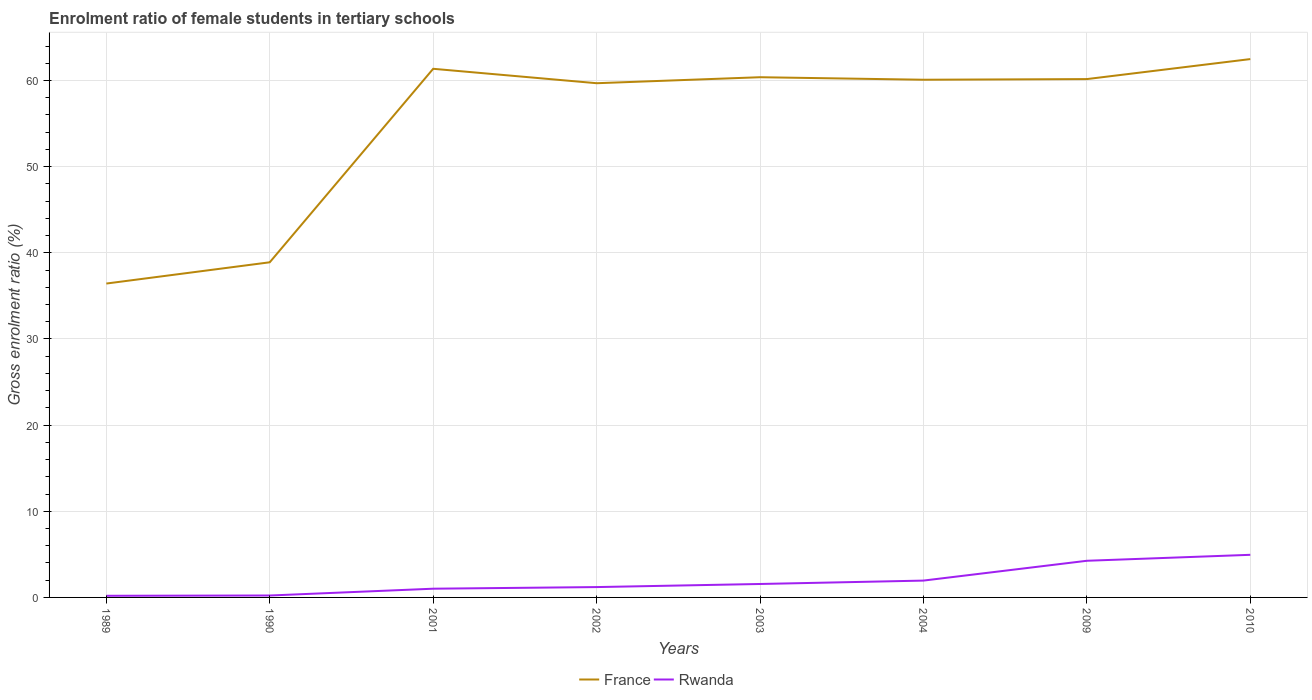How many different coloured lines are there?
Ensure brevity in your answer.  2. Across all years, what is the maximum enrolment ratio of female students in tertiary schools in Rwanda?
Your answer should be compact. 0.19. In which year was the enrolment ratio of female students in tertiary schools in France maximum?
Your answer should be compact. 1989. What is the total enrolment ratio of female students in tertiary schools in Rwanda in the graph?
Give a very brief answer. -2.69. What is the difference between the highest and the second highest enrolment ratio of female students in tertiary schools in France?
Offer a terse response. 26.05. What is the difference between the highest and the lowest enrolment ratio of female students in tertiary schools in Rwanda?
Provide a succinct answer. 3. How many lines are there?
Provide a succinct answer. 2. How many years are there in the graph?
Keep it short and to the point. 8. What is the title of the graph?
Your answer should be very brief. Enrolment ratio of female students in tertiary schools. Does "Ireland" appear as one of the legend labels in the graph?
Keep it short and to the point. No. What is the label or title of the Y-axis?
Offer a terse response. Gross enrolment ratio (%). What is the Gross enrolment ratio (%) of France in 1989?
Your answer should be compact. 36.43. What is the Gross enrolment ratio (%) of Rwanda in 1989?
Keep it short and to the point. 0.19. What is the Gross enrolment ratio (%) of France in 1990?
Provide a short and direct response. 38.9. What is the Gross enrolment ratio (%) in Rwanda in 1990?
Give a very brief answer. 0.22. What is the Gross enrolment ratio (%) of France in 2001?
Provide a succinct answer. 61.36. What is the Gross enrolment ratio (%) of Rwanda in 2001?
Provide a short and direct response. 1.01. What is the Gross enrolment ratio (%) in France in 2002?
Offer a very short reply. 59.68. What is the Gross enrolment ratio (%) of Rwanda in 2002?
Make the answer very short. 1.2. What is the Gross enrolment ratio (%) of France in 2003?
Offer a very short reply. 60.38. What is the Gross enrolment ratio (%) of Rwanda in 2003?
Provide a short and direct response. 1.56. What is the Gross enrolment ratio (%) in France in 2004?
Provide a short and direct response. 60.09. What is the Gross enrolment ratio (%) of Rwanda in 2004?
Your response must be concise. 1.95. What is the Gross enrolment ratio (%) of France in 2009?
Provide a short and direct response. 60.16. What is the Gross enrolment ratio (%) in Rwanda in 2009?
Provide a short and direct response. 4.25. What is the Gross enrolment ratio (%) in France in 2010?
Keep it short and to the point. 62.48. What is the Gross enrolment ratio (%) in Rwanda in 2010?
Ensure brevity in your answer.  4.95. Across all years, what is the maximum Gross enrolment ratio (%) in France?
Offer a terse response. 62.48. Across all years, what is the maximum Gross enrolment ratio (%) of Rwanda?
Offer a very short reply. 4.95. Across all years, what is the minimum Gross enrolment ratio (%) in France?
Offer a terse response. 36.43. Across all years, what is the minimum Gross enrolment ratio (%) of Rwanda?
Provide a short and direct response. 0.19. What is the total Gross enrolment ratio (%) in France in the graph?
Keep it short and to the point. 439.49. What is the total Gross enrolment ratio (%) in Rwanda in the graph?
Offer a terse response. 15.35. What is the difference between the Gross enrolment ratio (%) in France in 1989 and that in 1990?
Keep it short and to the point. -2.47. What is the difference between the Gross enrolment ratio (%) of Rwanda in 1989 and that in 1990?
Provide a short and direct response. -0.03. What is the difference between the Gross enrolment ratio (%) of France in 1989 and that in 2001?
Your answer should be compact. -24.93. What is the difference between the Gross enrolment ratio (%) in Rwanda in 1989 and that in 2001?
Your answer should be very brief. -0.82. What is the difference between the Gross enrolment ratio (%) of France in 1989 and that in 2002?
Ensure brevity in your answer.  -23.25. What is the difference between the Gross enrolment ratio (%) in Rwanda in 1989 and that in 2002?
Ensure brevity in your answer.  -1.01. What is the difference between the Gross enrolment ratio (%) in France in 1989 and that in 2003?
Provide a short and direct response. -23.95. What is the difference between the Gross enrolment ratio (%) in Rwanda in 1989 and that in 2003?
Provide a succinct answer. -1.37. What is the difference between the Gross enrolment ratio (%) in France in 1989 and that in 2004?
Give a very brief answer. -23.66. What is the difference between the Gross enrolment ratio (%) of Rwanda in 1989 and that in 2004?
Your response must be concise. -1.76. What is the difference between the Gross enrolment ratio (%) of France in 1989 and that in 2009?
Your response must be concise. -23.73. What is the difference between the Gross enrolment ratio (%) in Rwanda in 1989 and that in 2009?
Offer a very short reply. -4.06. What is the difference between the Gross enrolment ratio (%) of France in 1989 and that in 2010?
Make the answer very short. -26.05. What is the difference between the Gross enrolment ratio (%) in Rwanda in 1989 and that in 2010?
Give a very brief answer. -4.75. What is the difference between the Gross enrolment ratio (%) of France in 1990 and that in 2001?
Make the answer very short. -22.46. What is the difference between the Gross enrolment ratio (%) of Rwanda in 1990 and that in 2001?
Your response must be concise. -0.79. What is the difference between the Gross enrolment ratio (%) in France in 1990 and that in 2002?
Make the answer very short. -20.78. What is the difference between the Gross enrolment ratio (%) of Rwanda in 1990 and that in 2002?
Make the answer very short. -0.98. What is the difference between the Gross enrolment ratio (%) of France in 1990 and that in 2003?
Give a very brief answer. -21.48. What is the difference between the Gross enrolment ratio (%) of Rwanda in 1990 and that in 2003?
Keep it short and to the point. -1.34. What is the difference between the Gross enrolment ratio (%) of France in 1990 and that in 2004?
Give a very brief answer. -21.19. What is the difference between the Gross enrolment ratio (%) in Rwanda in 1990 and that in 2004?
Offer a terse response. -1.73. What is the difference between the Gross enrolment ratio (%) in France in 1990 and that in 2009?
Your answer should be very brief. -21.26. What is the difference between the Gross enrolment ratio (%) of Rwanda in 1990 and that in 2009?
Your answer should be compact. -4.03. What is the difference between the Gross enrolment ratio (%) of France in 1990 and that in 2010?
Your answer should be compact. -23.59. What is the difference between the Gross enrolment ratio (%) in Rwanda in 1990 and that in 2010?
Your answer should be compact. -4.72. What is the difference between the Gross enrolment ratio (%) in France in 2001 and that in 2002?
Your answer should be compact. 1.67. What is the difference between the Gross enrolment ratio (%) in Rwanda in 2001 and that in 2002?
Offer a very short reply. -0.19. What is the difference between the Gross enrolment ratio (%) in France in 2001 and that in 2003?
Your answer should be compact. 0.98. What is the difference between the Gross enrolment ratio (%) in Rwanda in 2001 and that in 2003?
Offer a terse response. -0.55. What is the difference between the Gross enrolment ratio (%) in France in 2001 and that in 2004?
Make the answer very short. 1.27. What is the difference between the Gross enrolment ratio (%) in Rwanda in 2001 and that in 2004?
Make the answer very short. -0.94. What is the difference between the Gross enrolment ratio (%) in France in 2001 and that in 2009?
Keep it short and to the point. 1.2. What is the difference between the Gross enrolment ratio (%) in Rwanda in 2001 and that in 2009?
Your response must be concise. -3.24. What is the difference between the Gross enrolment ratio (%) in France in 2001 and that in 2010?
Provide a short and direct response. -1.13. What is the difference between the Gross enrolment ratio (%) in Rwanda in 2001 and that in 2010?
Provide a short and direct response. -3.93. What is the difference between the Gross enrolment ratio (%) of France in 2002 and that in 2003?
Your response must be concise. -0.7. What is the difference between the Gross enrolment ratio (%) in Rwanda in 2002 and that in 2003?
Your answer should be very brief. -0.36. What is the difference between the Gross enrolment ratio (%) in France in 2002 and that in 2004?
Your answer should be very brief. -0.4. What is the difference between the Gross enrolment ratio (%) in Rwanda in 2002 and that in 2004?
Give a very brief answer. -0.75. What is the difference between the Gross enrolment ratio (%) in France in 2002 and that in 2009?
Your response must be concise. -0.48. What is the difference between the Gross enrolment ratio (%) in Rwanda in 2002 and that in 2009?
Your answer should be very brief. -3.05. What is the difference between the Gross enrolment ratio (%) in France in 2002 and that in 2010?
Give a very brief answer. -2.8. What is the difference between the Gross enrolment ratio (%) in Rwanda in 2002 and that in 2010?
Provide a short and direct response. -3.75. What is the difference between the Gross enrolment ratio (%) of France in 2003 and that in 2004?
Ensure brevity in your answer.  0.29. What is the difference between the Gross enrolment ratio (%) in Rwanda in 2003 and that in 2004?
Keep it short and to the point. -0.39. What is the difference between the Gross enrolment ratio (%) in France in 2003 and that in 2009?
Provide a succinct answer. 0.22. What is the difference between the Gross enrolment ratio (%) of Rwanda in 2003 and that in 2009?
Provide a succinct answer. -2.69. What is the difference between the Gross enrolment ratio (%) of France in 2003 and that in 2010?
Your answer should be very brief. -2.1. What is the difference between the Gross enrolment ratio (%) of Rwanda in 2003 and that in 2010?
Provide a short and direct response. -3.39. What is the difference between the Gross enrolment ratio (%) in France in 2004 and that in 2009?
Offer a terse response. -0.07. What is the difference between the Gross enrolment ratio (%) of Rwanda in 2004 and that in 2009?
Provide a short and direct response. -2.3. What is the difference between the Gross enrolment ratio (%) in France in 2004 and that in 2010?
Make the answer very short. -2.4. What is the difference between the Gross enrolment ratio (%) of Rwanda in 2004 and that in 2010?
Ensure brevity in your answer.  -2.99. What is the difference between the Gross enrolment ratio (%) of France in 2009 and that in 2010?
Give a very brief answer. -2.32. What is the difference between the Gross enrolment ratio (%) in Rwanda in 2009 and that in 2010?
Keep it short and to the point. -0.69. What is the difference between the Gross enrolment ratio (%) in France in 1989 and the Gross enrolment ratio (%) in Rwanda in 1990?
Offer a very short reply. 36.21. What is the difference between the Gross enrolment ratio (%) of France in 1989 and the Gross enrolment ratio (%) of Rwanda in 2001?
Provide a short and direct response. 35.42. What is the difference between the Gross enrolment ratio (%) in France in 1989 and the Gross enrolment ratio (%) in Rwanda in 2002?
Provide a short and direct response. 35.23. What is the difference between the Gross enrolment ratio (%) of France in 1989 and the Gross enrolment ratio (%) of Rwanda in 2003?
Your answer should be very brief. 34.87. What is the difference between the Gross enrolment ratio (%) of France in 1989 and the Gross enrolment ratio (%) of Rwanda in 2004?
Make the answer very short. 34.48. What is the difference between the Gross enrolment ratio (%) in France in 1989 and the Gross enrolment ratio (%) in Rwanda in 2009?
Your answer should be very brief. 32.18. What is the difference between the Gross enrolment ratio (%) in France in 1989 and the Gross enrolment ratio (%) in Rwanda in 2010?
Your answer should be very brief. 31.48. What is the difference between the Gross enrolment ratio (%) in France in 1990 and the Gross enrolment ratio (%) in Rwanda in 2001?
Offer a terse response. 37.89. What is the difference between the Gross enrolment ratio (%) in France in 1990 and the Gross enrolment ratio (%) in Rwanda in 2002?
Give a very brief answer. 37.7. What is the difference between the Gross enrolment ratio (%) in France in 1990 and the Gross enrolment ratio (%) in Rwanda in 2003?
Your response must be concise. 37.34. What is the difference between the Gross enrolment ratio (%) in France in 1990 and the Gross enrolment ratio (%) in Rwanda in 2004?
Your response must be concise. 36.94. What is the difference between the Gross enrolment ratio (%) in France in 1990 and the Gross enrolment ratio (%) in Rwanda in 2009?
Provide a short and direct response. 34.65. What is the difference between the Gross enrolment ratio (%) of France in 1990 and the Gross enrolment ratio (%) of Rwanda in 2010?
Give a very brief answer. 33.95. What is the difference between the Gross enrolment ratio (%) of France in 2001 and the Gross enrolment ratio (%) of Rwanda in 2002?
Make the answer very short. 60.16. What is the difference between the Gross enrolment ratio (%) in France in 2001 and the Gross enrolment ratio (%) in Rwanda in 2003?
Your answer should be compact. 59.8. What is the difference between the Gross enrolment ratio (%) of France in 2001 and the Gross enrolment ratio (%) of Rwanda in 2004?
Keep it short and to the point. 59.4. What is the difference between the Gross enrolment ratio (%) in France in 2001 and the Gross enrolment ratio (%) in Rwanda in 2009?
Your answer should be compact. 57.1. What is the difference between the Gross enrolment ratio (%) in France in 2001 and the Gross enrolment ratio (%) in Rwanda in 2010?
Keep it short and to the point. 56.41. What is the difference between the Gross enrolment ratio (%) in France in 2002 and the Gross enrolment ratio (%) in Rwanda in 2003?
Provide a succinct answer. 58.12. What is the difference between the Gross enrolment ratio (%) of France in 2002 and the Gross enrolment ratio (%) of Rwanda in 2004?
Ensure brevity in your answer.  57.73. What is the difference between the Gross enrolment ratio (%) in France in 2002 and the Gross enrolment ratio (%) in Rwanda in 2009?
Offer a terse response. 55.43. What is the difference between the Gross enrolment ratio (%) of France in 2002 and the Gross enrolment ratio (%) of Rwanda in 2010?
Keep it short and to the point. 54.74. What is the difference between the Gross enrolment ratio (%) in France in 2003 and the Gross enrolment ratio (%) in Rwanda in 2004?
Give a very brief answer. 58.43. What is the difference between the Gross enrolment ratio (%) in France in 2003 and the Gross enrolment ratio (%) in Rwanda in 2009?
Your response must be concise. 56.13. What is the difference between the Gross enrolment ratio (%) of France in 2003 and the Gross enrolment ratio (%) of Rwanda in 2010?
Provide a succinct answer. 55.43. What is the difference between the Gross enrolment ratio (%) in France in 2004 and the Gross enrolment ratio (%) in Rwanda in 2009?
Offer a terse response. 55.83. What is the difference between the Gross enrolment ratio (%) of France in 2004 and the Gross enrolment ratio (%) of Rwanda in 2010?
Your response must be concise. 55.14. What is the difference between the Gross enrolment ratio (%) in France in 2009 and the Gross enrolment ratio (%) in Rwanda in 2010?
Provide a succinct answer. 55.22. What is the average Gross enrolment ratio (%) in France per year?
Provide a short and direct response. 54.94. What is the average Gross enrolment ratio (%) of Rwanda per year?
Provide a short and direct response. 1.92. In the year 1989, what is the difference between the Gross enrolment ratio (%) in France and Gross enrolment ratio (%) in Rwanda?
Ensure brevity in your answer.  36.24. In the year 1990, what is the difference between the Gross enrolment ratio (%) of France and Gross enrolment ratio (%) of Rwanda?
Make the answer very short. 38.68. In the year 2001, what is the difference between the Gross enrolment ratio (%) of France and Gross enrolment ratio (%) of Rwanda?
Make the answer very short. 60.34. In the year 2002, what is the difference between the Gross enrolment ratio (%) in France and Gross enrolment ratio (%) in Rwanda?
Give a very brief answer. 58.48. In the year 2003, what is the difference between the Gross enrolment ratio (%) of France and Gross enrolment ratio (%) of Rwanda?
Keep it short and to the point. 58.82. In the year 2004, what is the difference between the Gross enrolment ratio (%) of France and Gross enrolment ratio (%) of Rwanda?
Ensure brevity in your answer.  58.13. In the year 2009, what is the difference between the Gross enrolment ratio (%) of France and Gross enrolment ratio (%) of Rwanda?
Ensure brevity in your answer.  55.91. In the year 2010, what is the difference between the Gross enrolment ratio (%) in France and Gross enrolment ratio (%) in Rwanda?
Make the answer very short. 57.54. What is the ratio of the Gross enrolment ratio (%) of France in 1989 to that in 1990?
Provide a short and direct response. 0.94. What is the ratio of the Gross enrolment ratio (%) in Rwanda in 1989 to that in 1990?
Offer a terse response. 0.86. What is the ratio of the Gross enrolment ratio (%) of France in 1989 to that in 2001?
Offer a terse response. 0.59. What is the ratio of the Gross enrolment ratio (%) of Rwanda in 1989 to that in 2001?
Ensure brevity in your answer.  0.19. What is the ratio of the Gross enrolment ratio (%) in France in 1989 to that in 2002?
Your answer should be compact. 0.61. What is the ratio of the Gross enrolment ratio (%) in Rwanda in 1989 to that in 2002?
Offer a terse response. 0.16. What is the ratio of the Gross enrolment ratio (%) in France in 1989 to that in 2003?
Offer a terse response. 0.6. What is the ratio of the Gross enrolment ratio (%) in Rwanda in 1989 to that in 2003?
Your answer should be very brief. 0.12. What is the ratio of the Gross enrolment ratio (%) in France in 1989 to that in 2004?
Ensure brevity in your answer.  0.61. What is the ratio of the Gross enrolment ratio (%) of Rwanda in 1989 to that in 2004?
Offer a very short reply. 0.1. What is the ratio of the Gross enrolment ratio (%) in France in 1989 to that in 2009?
Your answer should be very brief. 0.61. What is the ratio of the Gross enrolment ratio (%) of Rwanda in 1989 to that in 2009?
Your answer should be compact. 0.04. What is the ratio of the Gross enrolment ratio (%) in France in 1989 to that in 2010?
Your answer should be very brief. 0.58. What is the ratio of the Gross enrolment ratio (%) of Rwanda in 1989 to that in 2010?
Make the answer very short. 0.04. What is the ratio of the Gross enrolment ratio (%) of France in 1990 to that in 2001?
Give a very brief answer. 0.63. What is the ratio of the Gross enrolment ratio (%) of Rwanda in 1990 to that in 2001?
Your answer should be compact. 0.22. What is the ratio of the Gross enrolment ratio (%) of France in 1990 to that in 2002?
Keep it short and to the point. 0.65. What is the ratio of the Gross enrolment ratio (%) of Rwanda in 1990 to that in 2002?
Give a very brief answer. 0.19. What is the ratio of the Gross enrolment ratio (%) of France in 1990 to that in 2003?
Provide a succinct answer. 0.64. What is the ratio of the Gross enrolment ratio (%) in Rwanda in 1990 to that in 2003?
Provide a short and direct response. 0.14. What is the ratio of the Gross enrolment ratio (%) in France in 1990 to that in 2004?
Provide a short and direct response. 0.65. What is the ratio of the Gross enrolment ratio (%) in Rwanda in 1990 to that in 2004?
Your answer should be compact. 0.11. What is the ratio of the Gross enrolment ratio (%) of France in 1990 to that in 2009?
Provide a short and direct response. 0.65. What is the ratio of the Gross enrolment ratio (%) in Rwanda in 1990 to that in 2009?
Provide a succinct answer. 0.05. What is the ratio of the Gross enrolment ratio (%) in France in 1990 to that in 2010?
Your answer should be compact. 0.62. What is the ratio of the Gross enrolment ratio (%) in Rwanda in 1990 to that in 2010?
Provide a succinct answer. 0.04. What is the ratio of the Gross enrolment ratio (%) in France in 2001 to that in 2002?
Your answer should be very brief. 1.03. What is the ratio of the Gross enrolment ratio (%) in Rwanda in 2001 to that in 2002?
Ensure brevity in your answer.  0.84. What is the ratio of the Gross enrolment ratio (%) in France in 2001 to that in 2003?
Provide a short and direct response. 1.02. What is the ratio of the Gross enrolment ratio (%) of Rwanda in 2001 to that in 2003?
Your answer should be compact. 0.65. What is the ratio of the Gross enrolment ratio (%) of France in 2001 to that in 2004?
Provide a succinct answer. 1.02. What is the ratio of the Gross enrolment ratio (%) in Rwanda in 2001 to that in 2004?
Offer a terse response. 0.52. What is the ratio of the Gross enrolment ratio (%) of France in 2001 to that in 2009?
Keep it short and to the point. 1.02. What is the ratio of the Gross enrolment ratio (%) of Rwanda in 2001 to that in 2009?
Your response must be concise. 0.24. What is the ratio of the Gross enrolment ratio (%) of Rwanda in 2001 to that in 2010?
Keep it short and to the point. 0.2. What is the ratio of the Gross enrolment ratio (%) in Rwanda in 2002 to that in 2003?
Your response must be concise. 0.77. What is the ratio of the Gross enrolment ratio (%) of France in 2002 to that in 2004?
Your answer should be very brief. 0.99. What is the ratio of the Gross enrolment ratio (%) in Rwanda in 2002 to that in 2004?
Provide a short and direct response. 0.61. What is the ratio of the Gross enrolment ratio (%) in Rwanda in 2002 to that in 2009?
Give a very brief answer. 0.28. What is the ratio of the Gross enrolment ratio (%) of France in 2002 to that in 2010?
Provide a succinct answer. 0.96. What is the ratio of the Gross enrolment ratio (%) of Rwanda in 2002 to that in 2010?
Your response must be concise. 0.24. What is the ratio of the Gross enrolment ratio (%) in Rwanda in 2003 to that in 2004?
Offer a terse response. 0.8. What is the ratio of the Gross enrolment ratio (%) of Rwanda in 2003 to that in 2009?
Make the answer very short. 0.37. What is the ratio of the Gross enrolment ratio (%) in France in 2003 to that in 2010?
Provide a succinct answer. 0.97. What is the ratio of the Gross enrolment ratio (%) of Rwanda in 2003 to that in 2010?
Provide a succinct answer. 0.32. What is the ratio of the Gross enrolment ratio (%) of Rwanda in 2004 to that in 2009?
Offer a very short reply. 0.46. What is the ratio of the Gross enrolment ratio (%) of France in 2004 to that in 2010?
Offer a terse response. 0.96. What is the ratio of the Gross enrolment ratio (%) in Rwanda in 2004 to that in 2010?
Your answer should be compact. 0.4. What is the ratio of the Gross enrolment ratio (%) in France in 2009 to that in 2010?
Your answer should be compact. 0.96. What is the ratio of the Gross enrolment ratio (%) of Rwanda in 2009 to that in 2010?
Provide a succinct answer. 0.86. What is the difference between the highest and the second highest Gross enrolment ratio (%) of France?
Offer a terse response. 1.13. What is the difference between the highest and the second highest Gross enrolment ratio (%) in Rwanda?
Offer a very short reply. 0.69. What is the difference between the highest and the lowest Gross enrolment ratio (%) of France?
Offer a terse response. 26.05. What is the difference between the highest and the lowest Gross enrolment ratio (%) of Rwanda?
Your answer should be very brief. 4.75. 